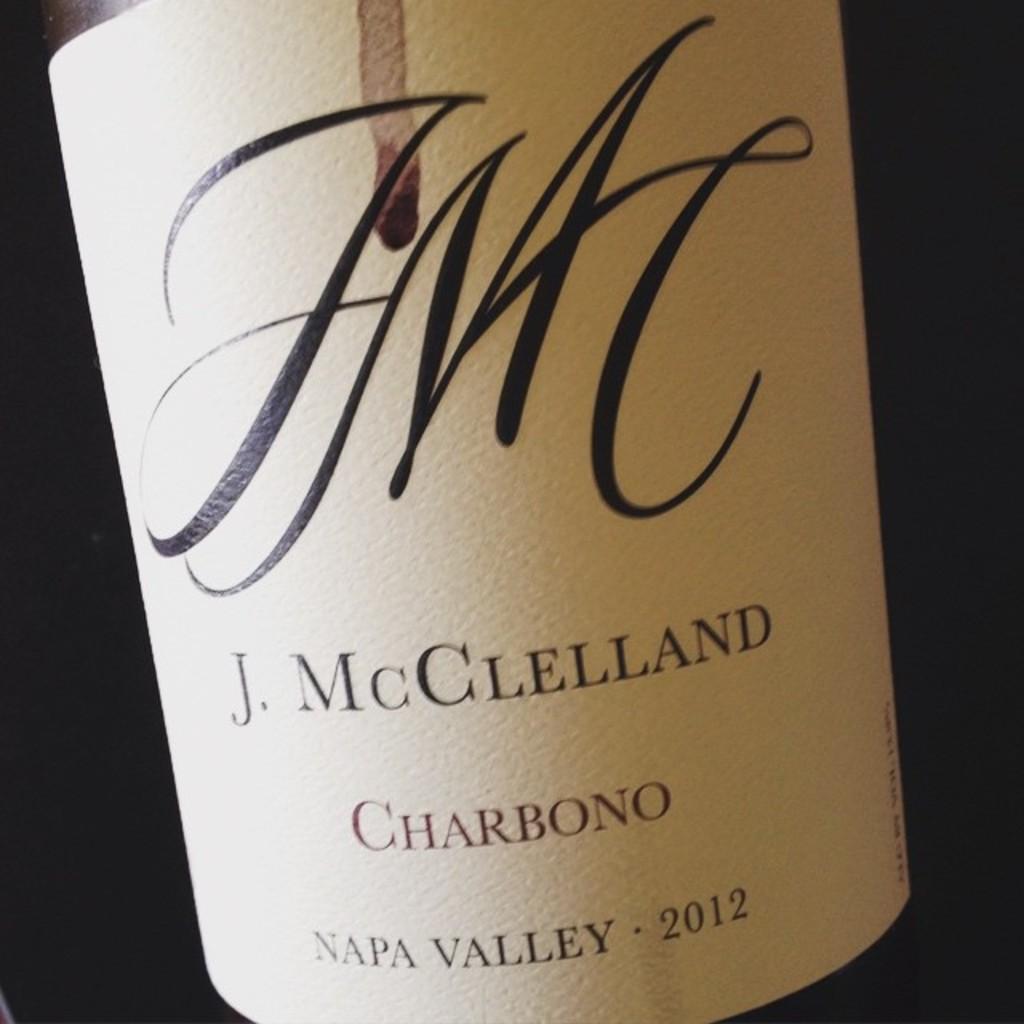Where was this wine bottled?
Your answer should be very brief. Napa valley. What year was it bottled?
Offer a very short reply. 2012. 